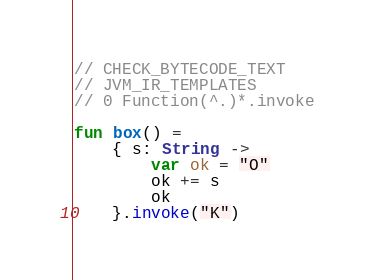<code> <loc_0><loc_0><loc_500><loc_500><_Kotlin_>// CHECK_BYTECODE_TEXT
// JVM_IR_TEMPLATES
// 0 Function(^.)*.invoke

fun box() =
    { s: String ->
        var ok = "O"
        ok += s
        ok
    }.invoke("K")
</code> 